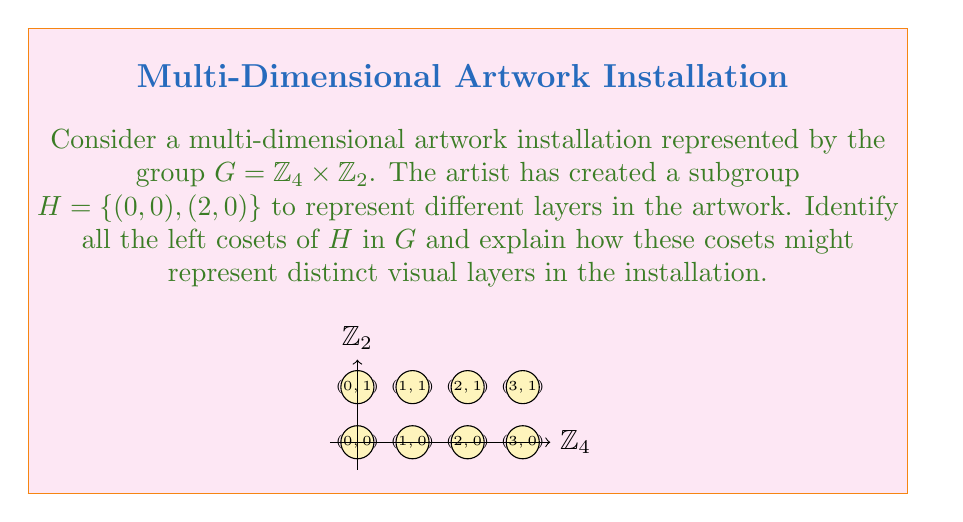What is the answer to this math problem? Let's approach this step-by-step:

1) First, recall that for a subgroup $H$ of a group $G$, the left cosets are of the form $gH$ where $g \in G$.

2) In this case, $G = \mathbb{Z}_4 \times \mathbb{Z}_2 = \{(0,0), (1,0), (2,0), (3,0), (0,1), (1,1), (2,1), (3,1)\}$

3) The subgroup $H = \{(0,0), (2,0)\}$

4) To find the left cosets, we multiply each element of $G$ with $H$:

   $(0,0)H = \{(0,0), (2,0)\}$
   $(1,0)H = \{(1,0), (3,0)\}$
   $(2,0)H = \{(2,0), (0,0)\} = (0,0)H$
   $(3,0)H = \{(3,0), (1,0)\} = (1,0)H$
   $(0,1)H = \{(0,1), (2,1)\}$
   $(1,1)H = \{(1,1), (3,1)\}$
   $(2,1)H = \{(2,1), (0,1)\} = (0,1)H$
   $(3,1)H = \{(3,1), (1,1)\} = (1,1)H$

5) We can see that there are four distinct left cosets:
   
   $H = (0,0)H = \{(0,0), (2,0)\}$
   $(1,0)H = \{(1,0), (3,0)\}$
   $(0,1)H = \{(0,1), (2,1)\}$
   $(1,1)H = \{(1,1), (3,1)\}$

6) In the context of the artwork installation:
   - Each coset could represent a distinct visual layer.
   - The elements within each coset might represent variations or sub-layers within that main layer.
   - The artist could use this structure to create depth, texture, or thematic groupings in the installation.
   - The cyclical nature of $\mathbb{Z}_4$ could be used to create patterns or repetitions within each layer.
   - The binary nature of $\mathbb{Z}_2$ could represent a duality or contrast between upper and lower parts of the installation.

This mathematical structure provides a framework for the artist to organize complex, multi-dimensional elements in their artwork, potentially creating a rich, layered visual experience.
Answer: $H, (1,0)H, (0,1)H, (1,1)H$ 